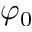Convert formula to latex. <formula><loc_0><loc_0><loc_500><loc_500>\varphi _ { 0 }</formula> 